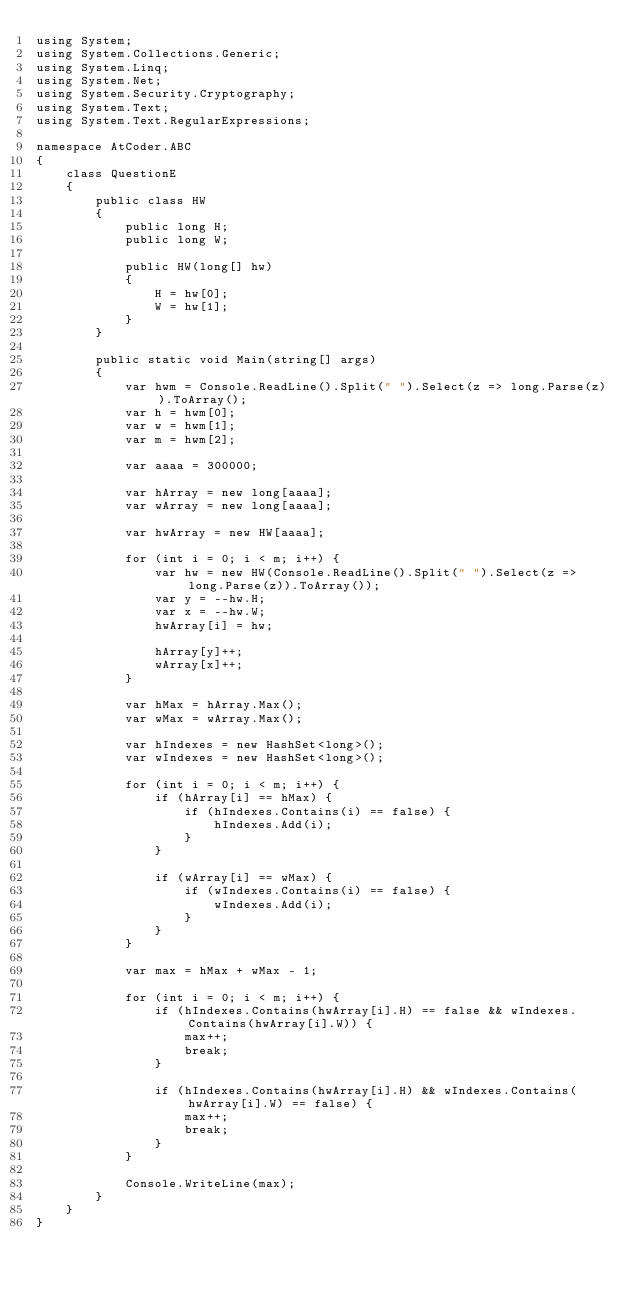Convert code to text. <code><loc_0><loc_0><loc_500><loc_500><_C#_>using System;
using System.Collections.Generic;
using System.Linq;
using System.Net;
using System.Security.Cryptography;
using System.Text;
using System.Text.RegularExpressions;

namespace AtCoder.ABC
{
    class QuestionE
    {
        public class HW
        {
            public long H;
            public long W;

            public HW(long[] hw)
            {
                H = hw[0];
                W = hw[1];
            }
        }

        public static void Main(string[] args)
        {
            var hwm = Console.ReadLine().Split(" ").Select(z => long.Parse(z)).ToArray();
            var h = hwm[0];
            var w = hwm[1];
            var m = hwm[2];

            var aaaa = 300000;

            var hArray = new long[aaaa];
            var wArray = new long[aaaa];

            var hwArray = new HW[aaaa];

            for (int i = 0; i < m; i++) {
                var hw = new HW(Console.ReadLine().Split(" ").Select(z => long.Parse(z)).ToArray());
                var y = --hw.H;
                var x = --hw.W;
                hwArray[i] = hw;

                hArray[y]++;
                wArray[x]++;
            }

            var hMax = hArray.Max();
            var wMax = wArray.Max();

            var hIndexes = new HashSet<long>();
            var wIndexes = new HashSet<long>();

            for (int i = 0; i < m; i++) {
                if (hArray[i] == hMax) {
                    if (hIndexes.Contains(i) == false) {
                        hIndexes.Add(i);
                    }
                }

                if (wArray[i] == wMax) {
                    if (wIndexes.Contains(i) == false) {
                        wIndexes.Add(i);
                    }
                }
            }
            
            var max = hMax + wMax - 1;

            for (int i = 0; i < m; i++) {
                if (hIndexes.Contains(hwArray[i].H) == false && wIndexes.Contains(hwArray[i].W)) {
                    max++;
                    break;
                }

                if (hIndexes.Contains(hwArray[i].H) && wIndexes.Contains(hwArray[i].W) == false) {
                    max++;
                    break;
                }
            }

            Console.WriteLine(max);
        }
    }
}
</code> 